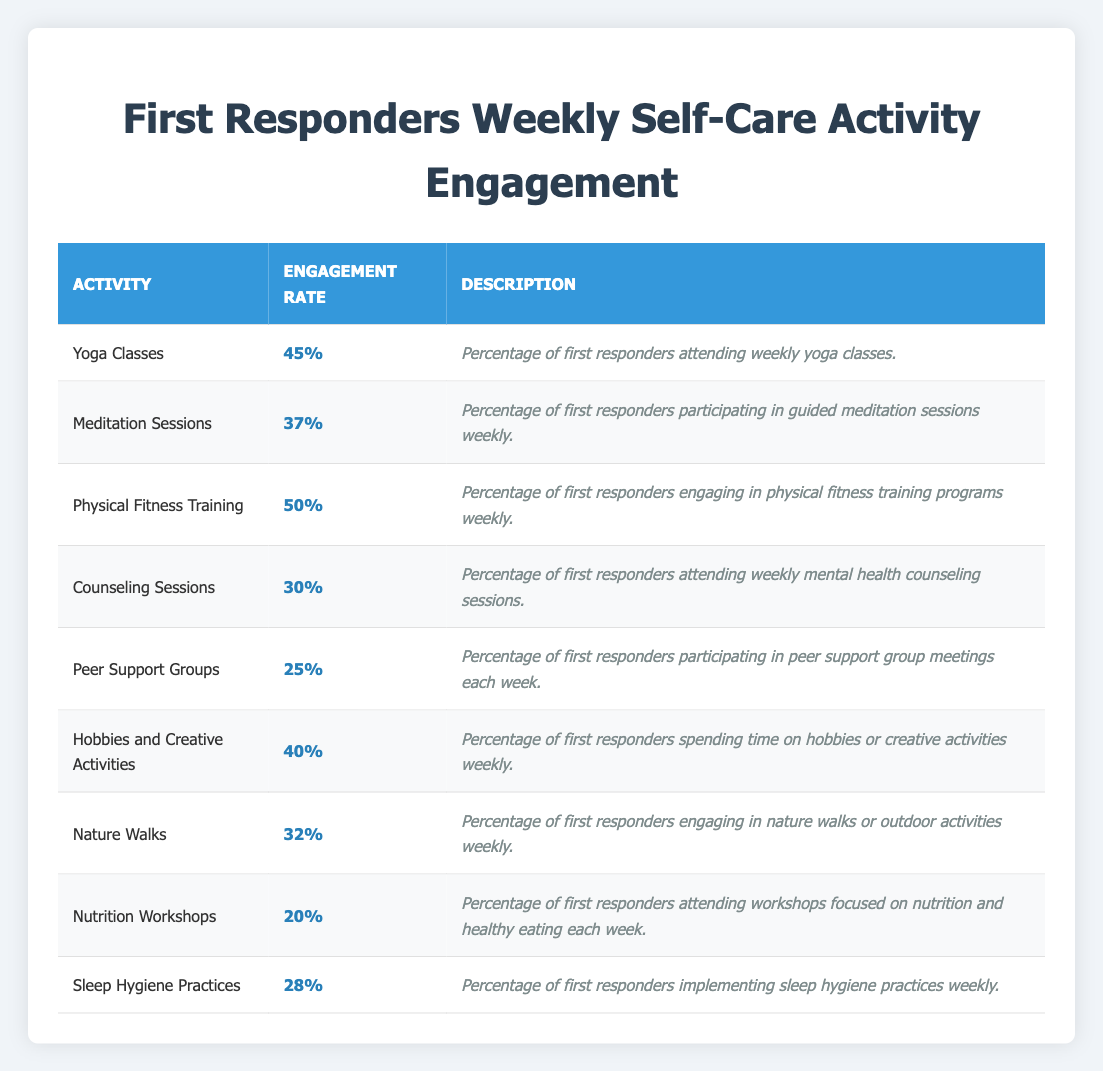What is the engagement rate for Physical Fitness Training? According to the table, the engagement rate for Physical Fitness Training is displayed in the corresponding row, which shows a rate of 50%.
Answer: 50% Which self-care activity has the highest engagement rate? By examining the engagement rates listed for each activity, Physical Fitness Training has the highest engagement rate at 50%, which is higher than all other activities.
Answer: Physical Fitness Training What is the average engagement rate of all activities listed in the table? To find the average, we need to sum up all engagement rates: 45 + 37 + 50 + 30 + 25 + 40 + 32 + 20 + 28 = 337. There are 9 activities, so the average engagement rate is 337 / 9 ≈ 37.44%.
Answer: Approximately 37.44% Do more than 40% of first responders engage in Yoga Classes? The engagement rate for Yoga Classes is shown as 45%, which is indeed more than 40%.
Answer: Yes What percentage difference is there between the engagement rates of Counseling Sessions and Peer Support Groups? The engagement rate for Counseling Sessions is 30%, and for Peer Support Groups, it is 25%. The difference is calculated as 30% - 25% = 5%.
Answer: 5% 